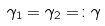Convert formula to latex. <formula><loc_0><loc_0><loc_500><loc_500>\gamma _ { 1 } = \gamma _ { 2 } = \colon \gamma</formula> 